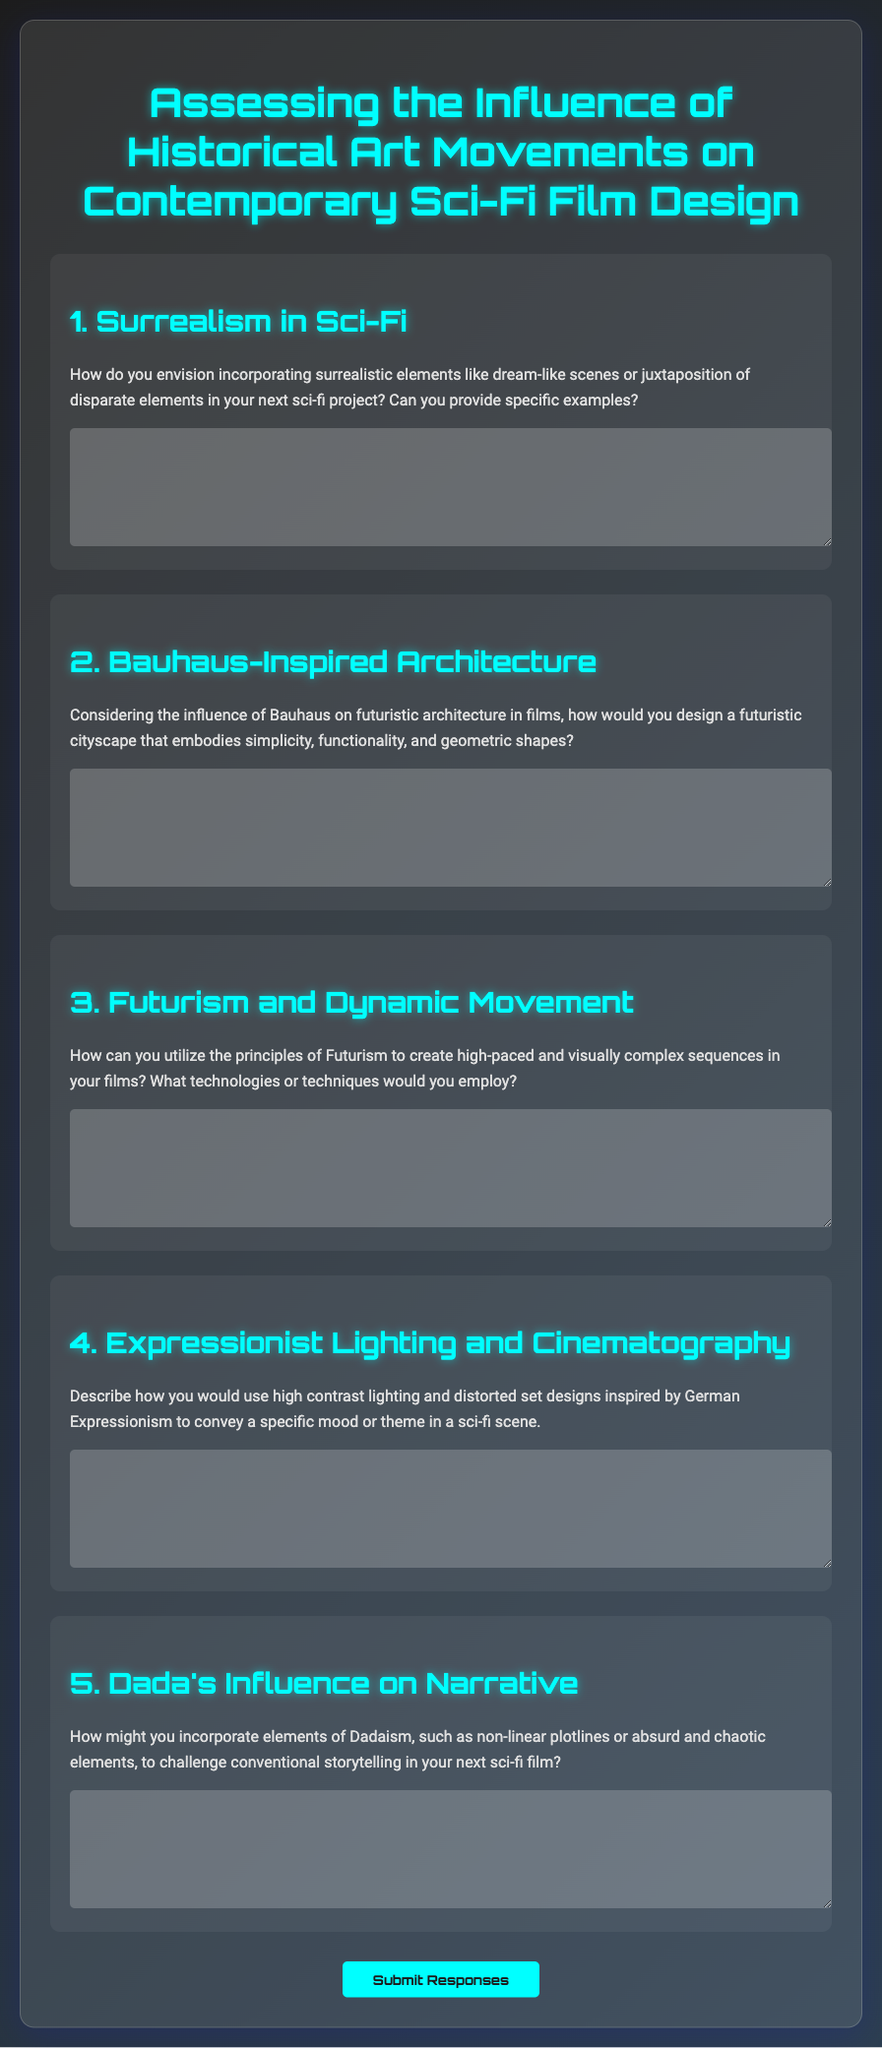What is the title of the document? The title is found in the header of the document, which is "Assessing the Influence of Historical Art Movements on Contemporary Sci-Fi Film Design."
Answer: Assessing the Influence of Historical Art Movements on Contemporary Sci-Fi Film Design How many questions are included in the questionnaire? The document contains five different questions organized under respective headings.
Answer: 5 What art movement is mentioned in question 1? The art movement referenced in question 1 is Surrealism.
Answer: Surrealism Which art movement does question 2 focus on? Question 2 specifically discusses the influence of Bauhaus on design.
Answer: Bauhaus What type of lighting is suggested in question 4? The question recommends using high contrast lighting, which is a technique related to German Expressionism.
Answer: High contrast lighting What is the submit button label in the questionnaire? The label on the submit button, which is found at the end of the form, is "Submit Responses."
Answer: Submit Responses In which style is the main heading styled? The main heading is styled using the "Orbitron" font, which gives it a futuristic appearance.
Answer: Orbitron What is the main design theme of the questionnaire's background? The background features a linear gradient with dark tones and a modern aesthetic, reflecting a futuristic theme.
Answer: Linear gradient with dark tones 